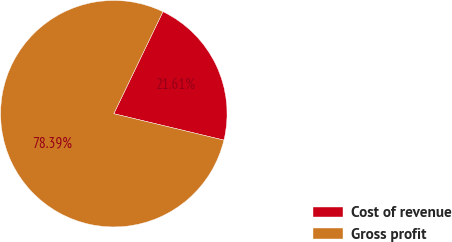<chart> <loc_0><loc_0><loc_500><loc_500><pie_chart><fcel>Cost of revenue<fcel>Gross profit<nl><fcel>21.61%<fcel>78.39%<nl></chart> 